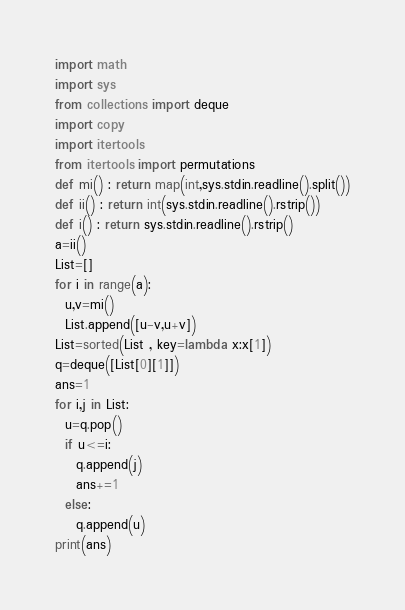<code> <loc_0><loc_0><loc_500><loc_500><_Python_>import math
import sys
from collections import deque
import copy
import itertools
from itertools import permutations
def mi() : return map(int,sys.stdin.readline().split())
def ii() : return int(sys.stdin.readline().rstrip())
def i() : return sys.stdin.readline().rstrip()
a=ii()
List=[]
for i in range(a):
  u,v=mi()
  List.append([u-v,u+v])
List=sorted(List , key=lambda x:x[1])
q=deque([List[0][1]])
ans=1
for i,j in List:
  u=q.pop()
  if u<=i:
    q.append(j)
    ans+=1
  else:
    q.append(u)
print(ans)</code> 